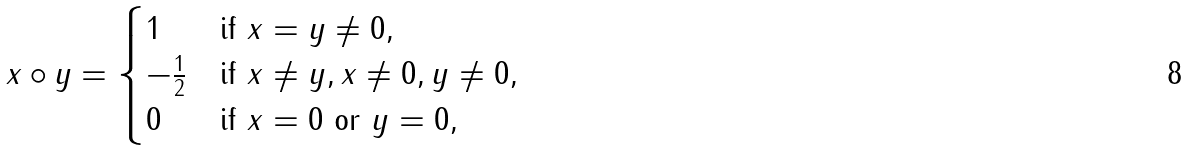Convert formula to latex. <formula><loc_0><loc_0><loc_500><loc_500>x \circ y = \begin{cases} 1 & \text {if } x = y \ne 0 , \\ - \frac { 1 } { 2 } & \text {if } x \ne y , x \ne 0 , y \ne 0 , \\ 0 & \text {if } x = 0 \text { or } y = 0 , \end{cases}</formula> 